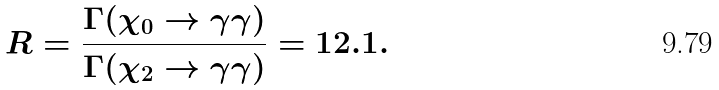Convert formula to latex. <formula><loc_0><loc_0><loc_500><loc_500>R = \frac { \Gamma ( \chi _ { 0 } \rightarrow \gamma \gamma ) } { \Gamma ( \chi _ { 2 } \rightarrow \gamma \gamma ) } = 1 2 . 1 .</formula> 